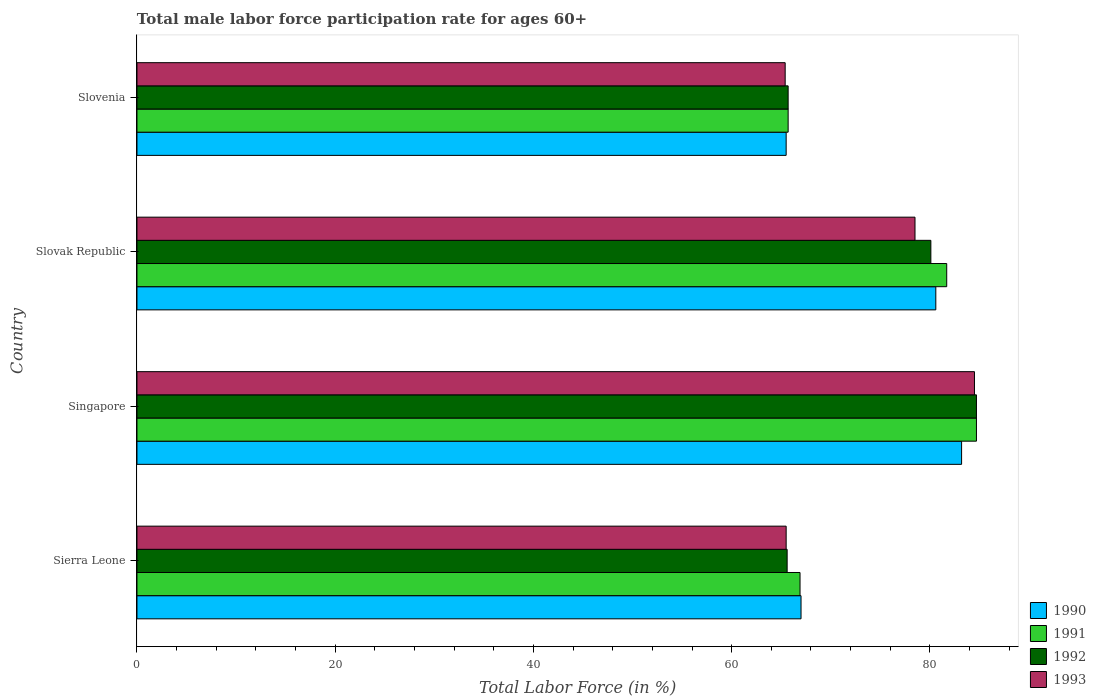Are the number of bars per tick equal to the number of legend labels?
Ensure brevity in your answer.  Yes. Are the number of bars on each tick of the Y-axis equal?
Make the answer very short. Yes. How many bars are there on the 4th tick from the top?
Your answer should be very brief. 4. What is the label of the 4th group of bars from the top?
Provide a short and direct response. Sierra Leone. In how many cases, is the number of bars for a given country not equal to the number of legend labels?
Your answer should be compact. 0. What is the male labor force participation rate in 1990 in Singapore?
Your answer should be compact. 83.2. Across all countries, what is the maximum male labor force participation rate in 1990?
Your answer should be compact. 83.2. Across all countries, what is the minimum male labor force participation rate in 1992?
Keep it short and to the point. 65.6. In which country was the male labor force participation rate in 1991 maximum?
Keep it short and to the point. Singapore. In which country was the male labor force participation rate in 1993 minimum?
Keep it short and to the point. Slovenia. What is the total male labor force participation rate in 1990 in the graph?
Give a very brief answer. 296.3. What is the difference between the male labor force participation rate in 1990 in Slovenia and the male labor force participation rate in 1991 in Slovak Republic?
Give a very brief answer. -16.2. What is the average male labor force participation rate in 1993 per country?
Ensure brevity in your answer.  73.48. What is the difference between the male labor force participation rate in 1992 and male labor force participation rate in 1993 in Slovak Republic?
Provide a short and direct response. 1.6. What is the ratio of the male labor force participation rate in 1992 in Singapore to that in Slovak Republic?
Offer a terse response. 1.06. Is the male labor force participation rate in 1993 in Sierra Leone less than that in Slovenia?
Provide a short and direct response. No. Is the difference between the male labor force participation rate in 1992 in Slovak Republic and Slovenia greater than the difference between the male labor force participation rate in 1993 in Slovak Republic and Slovenia?
Provide a succinct answer. Yes. What is the difference between the highest and the second highest male labor force participation rate in 1993?
Keep it short and to the point. 6. What is the difference between the highest and the lowest male labor force participation rate in 1992?
Keep it short and to the point. 19.1. Is it the case that in every country, the sum of the male labor force participation rate in 1990 and male labor force participation rate in 1991 is greater than the sum of male labor force participation rate in 1992 and male labor force participation rate in 1993?
Give a very brief answer. No. What does the 4th bar from the top in Slovak Republic represents?
Ensure brevity in your answer.  1990. What does the 2nd bar from the bottom in Singapore represents?
Ensure brevity in your answer.  1991. Are all the bars in the graph horizontal?
Provide a short and direct response. Yes. Are the values on the major ticks of X-axis written in scientific E-notation?
Offer a very short reply. No. Does the graph contain any zero values?
Make the answer very short. No. Does the graph contain grids?
Provide a short and direct response. No. Where does the legend appear in the graph?
Your response must be concise. Bottom right. What is the title of the graph?
Offer a terse response. Total male labor force participation rate for ages 60+. Does "1988" appear as one of the legend labels in the graph?
Make the answer very short. No. What is the label or title of the Y-axis?
Your response must be concise. Country. What is the Total Labor Force (in %) of 1991 in Sierra Leone?
Make the answer very short. 66.9. What is the Total Labor Force (in %) in 1992 in Sierra Leone?
Your response must be concise. 65.6. What is the Total Labor Force (in %) in 1993 in Sierra Leone?
Your response must be concise. 65.5. What is the Total Labor Force (in %) of 1990 in Singapore?
Ensure brevity in your answer.  83.2. What is the Total Labor Force (in %) of 1991 in Singapore?
Give a very brief answer. 84.7. What is the Total Labor Force (in %) of 1992 in Singapore?
Offer a terse response. 84.7. What is the Total Labor Force (in %) of 1993 in Singapore?
Provide a short and direct response. 84.5. What is the Total Labor Force (in %) in 1990 in Slovak Republic?
Make the answer very short. 80.6. What is the Total Labor Force (in %) in 1991 in Slovak Republic?
Provide a short and direct response. 81.7. What is the Total Labor Force (in %) in 1992 in Slovak Republic?
Give a very brief answer. 80.1. What is the Total Labor Force (in %) in 1993 in Slovak Republic?
Provide a short and direct response. 78.5. What is the Total Labor Force (in %) of 1990 in Slovenia?
Offer a very short reply. 65.5. What is the Total Labor Force (in %) in 1991 in Slovenia?
Ensure brevity in your answer.  65.7. What is the Total Labor Force (in %) of 1992 in Slovenia?
Give a very brief answer. 65.7. What is the Total Labor Force (in %) of 1993 in Slovenia?
Provide a succinct answer. 65.4. Across all countries, what is the maximum Total Labor Force (in %) in 1990?
Your response must be concise. 83.2. Across all countries, what is the maximum Total Labor Force (in %) of 1991?
Your response must be concise. 84.7. Across all countries, what is the maximum Total Labor Force (in %) in 1992?
Keep it short and to the point. 84.7. Across all countries, what is the maximum Total Labor Force (in %) of 1993?
Make the answer very short. 84.5. Across all countries, what is the minimum Total Labor Force (in %) in 1990?
Ensure brevity in your answer.  65.5. Across all countries, what is the minimum Total Labor Force (in %) in 1991?
Make the answer very short. 65.7. Across all countries, what is the minimum Total Labor Force (in %) of 1992?
Your response must be concise. 65.6. Across all countries, what is the minimum Total Labor Force (in %) of 1993?
Your answer should be compact. 65.4. What is the total Total Labor Force (in %) of 1990 in the graph?
Give a very brief answer. 296.3. What is the total Total Labor Force (in %) in 1991 in the graph?
Give a very brief answer. 299. What is the total Total Labor Force (in %) in 1992 in the graph?
Make the answer very short. 296.1. What is the total Total Labor Force (in %) in 1993 in the graph?
Offer a terse response. 293.9. What is the difference between the Total Labor Force (in %) in 1990 in Sierra Leone and that in Singapore?
Your response must be concise. -16.2. What is the difference between the Total Labor Force (in %) in 1991 in Sierra Leone and that in Singapore?
Provide a succinct answer. -17.8. What is the difference between the Total Labor Force (in %) of 1992 in Sierra Leone and that in Singapore?
Ensure brevity in your answer.  -19.1. What is the difference between the Total Labor Force (in %) in 1990 in Sierra Leone and that in Slovak Republic?
Ensure brevity in your answer.  -13.6. What is the difference between the Total Labor Force (in %) in 1991 in Sierra Leone and that in Slovak Republic?
Offer a terse response. -14.8. What is the difference between the Total Labor Force (in %) in 1993 in Sierra Leone and that in Slovak Republic?
Ensure brevity in your answer.  -13. What is the difference between the Total Labor Force (in %) in 1990 in Sierra Leone and that in Slovenia?
Your response must be concise. 1.5. What is the difference between the Total Labor Force (in %) of 1993 in Sierra Leone and that in Slovenia?
Offer a very short reply. 0.1. What is the difference between the Total Labor Force (in %) of 1990 in Singapore and that in Slovak Republic?
Ensure brevity in your answer.  2.6. What is the difference between the Total Labor Force (in %) of 1993 in Singapore and that in Slovak Republic?
Keep it short and to the point. 6. What is the difference between the Total Labor Force (in %) of 1991 in Singapore and that in Slovenia?
Give a very brief answer. 19. What is the difference between the Total Labor Force (in %) in 1992 in Singapore and that in Slovenia?
Make the answer very short. 19. What is the difference between the Total Labor Force (in %) in 1990 in Slovak Republic and that in Slovenia?
Your answer should be very brief. 15.1. What is the difference between the Total Labor Force (in %) in 1991 in Slovak Republic and that in Slovenia?
Give a very brief answer. 16. What is the difference between the Total Labor Force (in %) in 1992 in Slovak Republic and that in Slovenia?
Your answer should be compact. 14.4. What is the difference between the Total Labor Force (in %) of 1990 in Sierra Leone and the Total Labor Force (in %) of 1991 in Singapore?
Your answer should be very brief. -17.7. What is the difference between the Total Labor Force (in %) in 1990 in Sierra Leone and the Total Labor Force (in %) in 1992 in Singapore?
Your answer should be compact. -17.7. What is the difference between the Total Labor Force (in %) of 1990 in Sierra Leone and the Total Labor Force (in %) of 1993 in Singapore?
Provide a succinct answer. -17.5. What is the difference between the Total Labor Force (in %) in 1991 in Sierra Leone and the Total Labor Force (in %) in 1992 in Singapore?
Keep it short and to the point. -17.8. What is the difference between the Total Labor Force (in %) in 1991 in Sierra Leone and the Total Labor Force (in %) in 1993 in Singapore?
Make the answer very short. -17.6. What is the difference between the Total Labor Force (in %) in 1992 in Sierra Leone and the Total Labor Force (in %) in 1993 in Singapore?
Make the answer very short. -18.9. What is the difference between the Total Labor Force (in %) of 1990 in Sierra Leone and the Total Labor Force (in %) of 1991 in Slovak Republic?
Make the answer very short. -14.7. What is the difference between the Total Labor Force (in %) of 1990 in Sierra Leone and the Total Labor Force (in %) of 1993 in Slovak Republic?
Make the answer very short. -11.5. What is the difference between the Total Labor Force (in %) of 1991 in Sierra Leone and the Total Labor Force (in %) of 1993 in Slovak Republic?
Keep it short and to the point. -11.6. What is the difference between the Total Labor Force (in %) in 1990 in Sierra Leone and the Total Labor Force (in %) in 1991 in Slovenia?
Provide a short and direct response. 1.3. What is the difference between the Total Labor Force (in %) in 1990 in Sierra Leone and the Total Labor Force (in %) in 1993 in Slovenia?
Your answer should be compact. 1.6. What is the difference between the Total Labor Force (in %) in 1990 in Singapore and the Total Labor Force (in %) in 1993 in Slovak Republic?
Your response must be concise. 4.7. What is the difference between the Total Labor Force (in %) in 1991 in Singapore and the Total Labor Force (in %) in 1992 in Slovak Republic?
Offer a terse response. 4.6. What is the difference between the Total Labor Force (in %) of 1991 in Singapore and the Total Labor Force (in %) of 1993 in Slovak Republic?
Provide a succinct answer. 6.2. What is the difference between the Total Labor Force (in %) of 1992 in Singapore and the Total Labor Force (in %) of 1993 in Slovak Republic?
Offer a very short reply. 6.2. What is the difference between the Total Labor Force (in %) of 1990 in Singapore and the Total Labor Force (in %) of 1991 in Slovenia?
Offer a terse response. 17.5. What is the difference between the Total Labor Force (in %) in 1990 in Singapore and the Total Labor Force (in %) in 1992 in Slovenia?
Provide a short and direct response. 17.5. What is the difference between the Total Labor Force (in %) in 1990 in Singapore and the Total Labor Force (in %) in 1993 in Slovenia?
Ensure brevity in your answer.  17.8. What is the difference between the Total Labor Force (in %) in 1991 in Singapore and the Total Labor Force (in %) in 1992 in Slovenia?
Provide a succinct answer. 19. What is the difference between the Total Labor Force (in %) in 1991 in Singapore and the Total Labor Force (in %) in 1993 in Slovenia?
Your answer should be compact. 19.3. What is the difference between the Total Labor Force (in %) in 1992 in Singapore and the Total Labor Force (in %) in 1993 in Slovenia?
Offer a very short reply. 19.3. What is the difference between the Total Labor Force (in %) of 1990 in Slovak Republic and the Total Labor Force (in %) of 1993 in Slovenia?
Your answer should be compact. 15.2. What is the average Total Labor Force (in %) in 1990 per country?
Ensure brevity in your answer.  74.08. What is the average Total Labor Force (in %) in 1991 per country?
Your answer should be very brief. 74.75. What is the average Total Labor Force (in %) in 1992 per country?
Offer a very short reply. 74.03. What is the average Total Labor Force (in %) in 1993 per country?
Provide a succinct answer. 73.47. What is the difference between the Total Labor Force (in %) of 1991 and Total Labor Force (in %) of 1992 in Sierra Leone?
Ensure brevity in your answer.  1.3. What is the difference between the Total Labor Force (in %) of 1991 and Total Labor Force (in %) of 1993 in Sierra Leone?
Keep it short and to the point. 1.4. What is the difference between the Total Labor Force (in %) of 1992 and Total Labor Force (in %) of 1993 in Sierra Leone?
Ensure brevity in your answer.  0.1. What is the difference between the Total Labor Force (in %) in 1990 and Total Labor Force (in %) in 1993 in Singapore?
Offer a terse response. -1.3. What is the difference between the Total Labor Force (in %) in 1991 and Total Labor Force (in %) in 1993 in Singapore?
Make the answer very short. 0.2. What is the difference between the Total Labor Force (in %) in 1990 and Total Labor Force (in %) in 1991 in Slovak Republic?
Ensure brevity in your answer.  -1.1. What is the difference between the Total Labor Force (in %) in 1990 and Total Labor Force (in %) in 1993 in Slovak Republic?
Your response must be concise. 2.1. What is the difference between the Total Labor Force (in %) of 1991 and Total Labor Force (in %) of 1993 in Slovak Republic?
Offer a very short reply. 3.2. What is the difference between the Total Labor Force (in %) in 1992 and Total Labor Force (in %) in 1993 in Slovak Republic?
Provide a short and direct response. 1.6. What is the difference between the Total Labor Force (in %) of 1990 and Total Labor Force (in %) of 1992 in Slovenia?
Your response must be concise. -0.2. What is the difference between the Total Labor Force (in %) of 1990 and Total Labor Force (in %) of 1993 in Slovenia?
Your response must be concise. 0.1. What is the difference between the Total Labor Force (in %) of 1991 and Total Labor Force (in %) of 1992 in Slovenia?
Your response must be concise. 0. What is the ratio of the Total Labor Force (in %) of 1990 in Sierra Leone to that in Singapore?
Your response must be concise. 0.81. What is the ratio of the Total Labor Force (in %) in 1991 in Sierra Leone to that in Singapore?
Your response must be concise. 0.79. What is the ratio of the Total Labor Force (in %) in 1992 in Sierra Leone to that in Singapore?
Keep it short and to the point. 0.77. What is the ratio of the Total Labor Force (in %) of 1993 in Sierra Leone to that in Singapore?
Provide a short and direct response. 0.78. What is the ratio of the Total Labor Force (in %) of 1990 in Sierra Leone to that in Slovak Republic?
Offer a very short reply. 0.83. What is the ratio of the Total Labor Force (in %) in 1991 in Sierra Leone to that in Slovak Republic?
Ensure brevity in your answer.  0.82. What is the ratio of the Total Labor Force (in %) of 1992 in Sierra Leone to that in Slovak Republic?
Make the answer very short. 0.82. What is the ratio of the Total Labor Force (in %) in 1993 in Sierra Leone to that in Slovak Republic?
Give a very brief answer. 0.83. What is the ratio of the Total Labor Force (in %) in 1990 in Sierra Leone to that in Slovenia?
Offer a very short reply. 1.02. What is the ratio of the Total Labor Force (in %) of 1991 in Sierra Leone to that in Slovenia?
Offer a very short reply. 1.02. What is the ratio of the Total Labor Force (in %) of 1992 in Sierra Leone to that in Slovenia?
Your response must be concise. 1. What is the ratio of the Total Labor Force (in %) in 1990 in Singapore to that in Slovak Republic?
Offer a very short reply. 1.03. What is the ratio of the Total Labor Force (in %) of 1991 in Singapore to that in Slovak Republic?
Provide a short and direct response. 1.04. What is the ratio of the Total Labor Force (in %) of 1992 in Singapore to that in Slovak Republic?
Your answer should be compact. 1.06. What is the ratio of the Total Labor Force (in %) in 1993 in Singapore to that in Slovak Republic?
Make the answer very short. 1.08. What is the ratio of the Total Labor Force (in %) in 1990 in Singapore to that in Slovenia?
Give a very brief answer. 1.27. What is the ratio of the Total Labor Force (in %) in 1991 in Singapore to that in Slovenia?
Offer a very short reply. 1.29. What is the ratio of the Total Labor Force (in %) in 1992 in Singapore to that in Slovenia?
Your response must be concise. 1.29. What is the ratio of the Total Labor Force (in %) of 1993 in Singapore to that in Slovenia?
Offer a very short reply. 1.29. What is the ratio of the Total Labor Force (in %) in 1990 in Slovak Republic to that in Slovenia?
Offer a very short reply. 1.23. What is the ratio of the Total Labor Force (in %) in 1991 in Slovak Republic to that in Slovenia?
Your answer should be compact. 1.24. What is the ratio of the Total Labor Force (in %) in 1992 in Slovak Republic to that in Slovenia?
Your answer should be very brief. 1.22. What is the ratio of the Total Labor Force (in %) of 1993 in Slovak Republic to that in Slovenia?
Give a very brief answer. 1.2. What is the difference between the highest and the second highest Total Labor Force (in %) of 1992?
Ensure brevity in your answer.  4.6. What is the difference between the highest and the lowest Total Labor Force (in %) of 1991?
Make the answer very short. 19. What is the difference between the highest and the lowest Total Labor Force (in %) of 1992?
Your response must be concise. 19.1. What is the difference between the highest and the lowest Total Labor Force (in %) of 1993?
Provide a short and direct response. 19.1. 